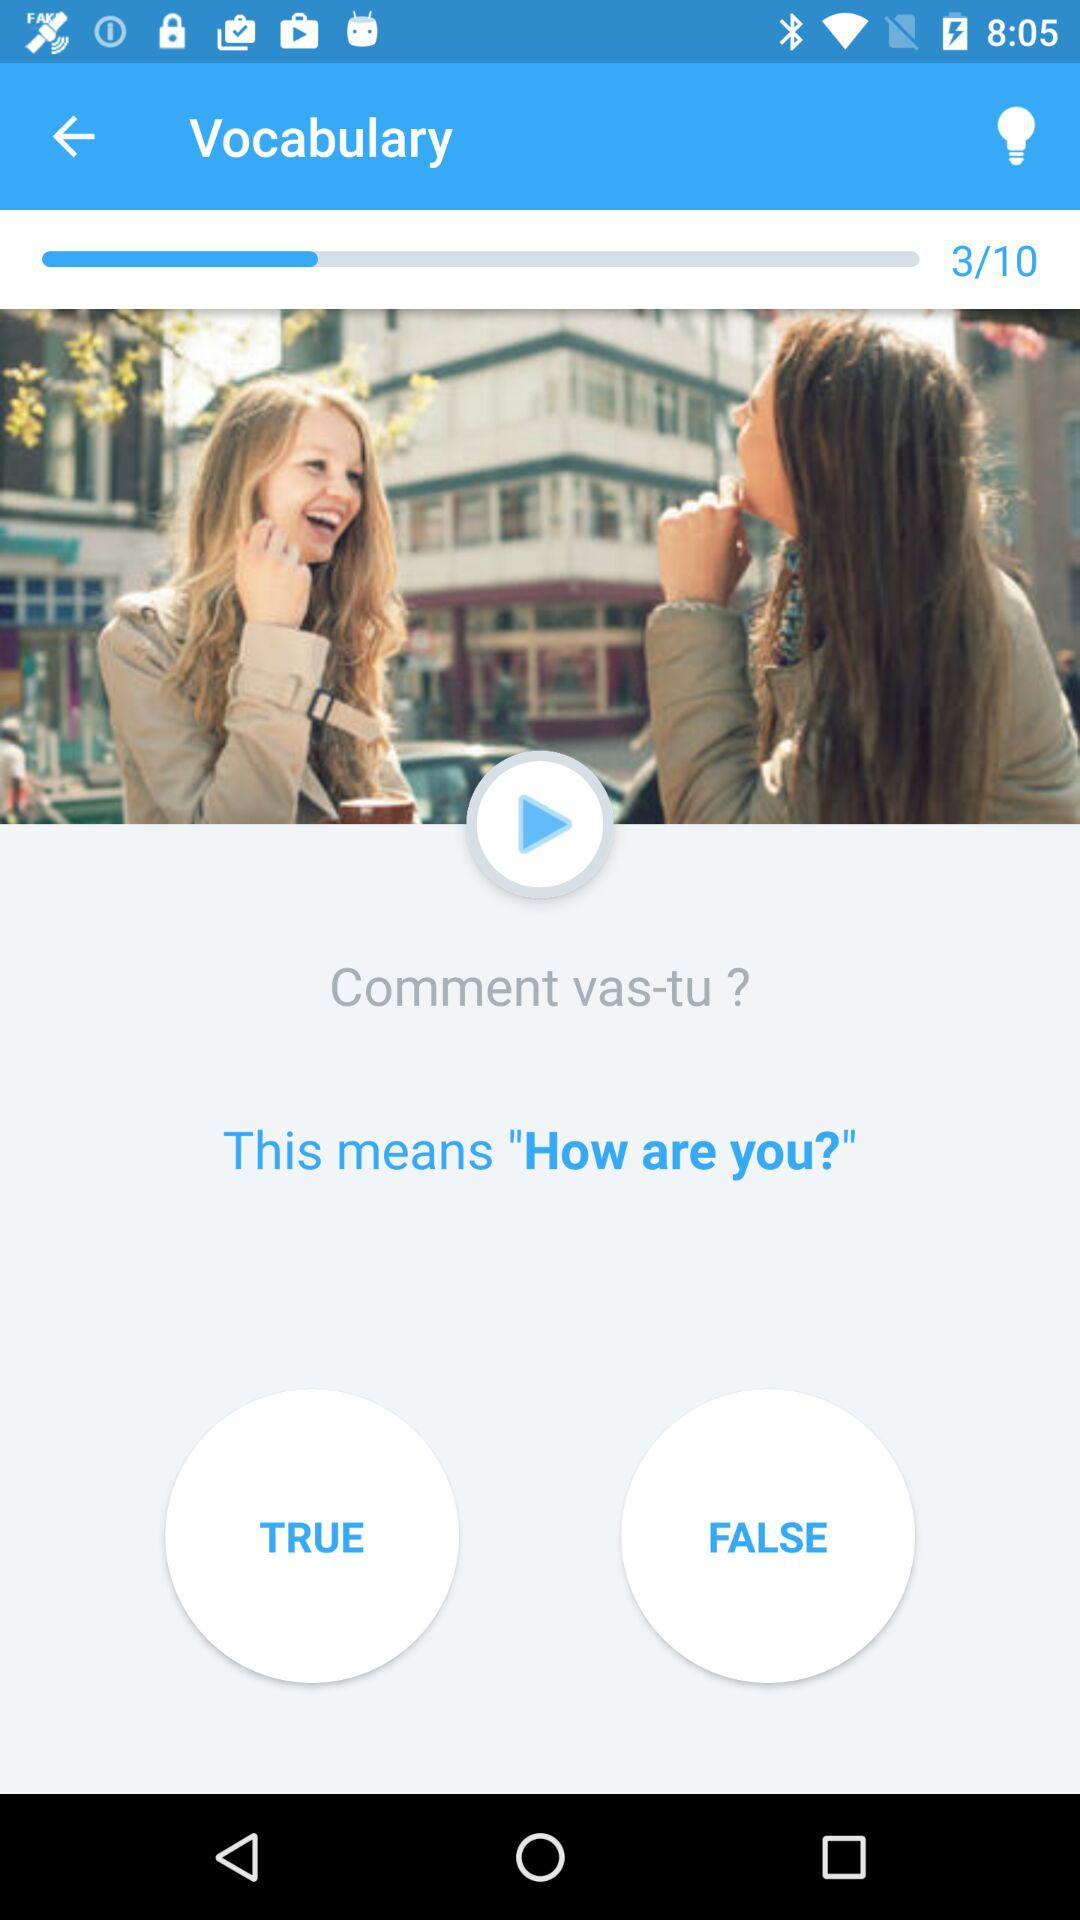How many questions in total are there? There are 10 questions in total. 